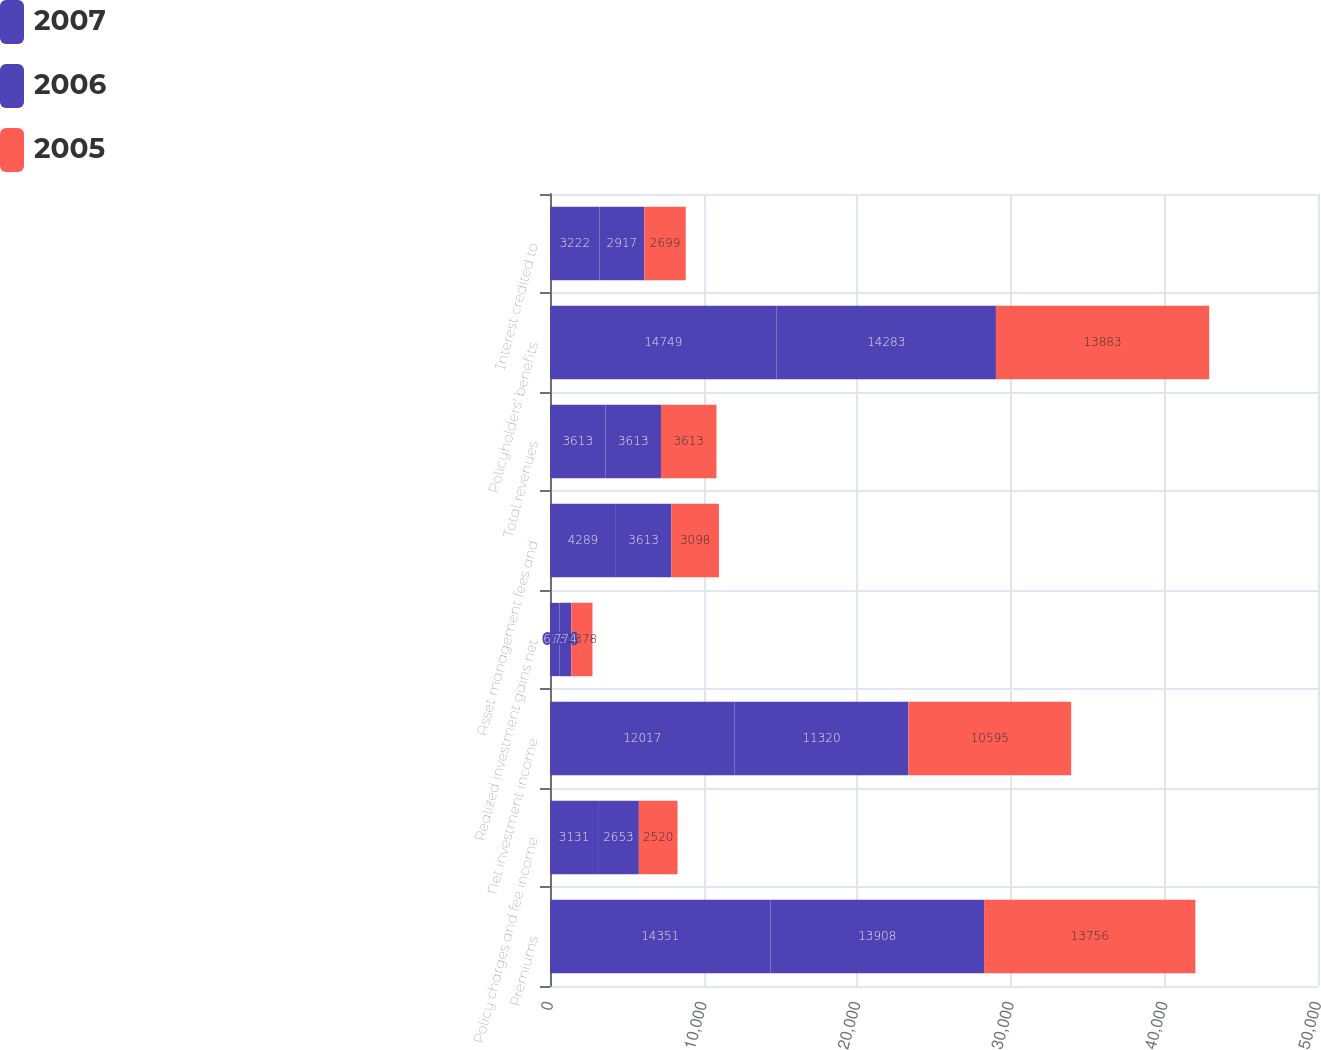Convert chart to OTSL. <chart><loc_0><loc_0><loc_500><loc_500><stacked_bar_chart><ecel><fcel>Premiums<fcel>Policy charges and fee income<fcel>Net investment income<fcel>Realized investment gains net<fcel>Asset management fees and<fcel>Total revenues<fcel>Policyholders' benefits<fcel>Interest credited to<nl><fcel>2007<fcel>14351<fcel>3131<fcel>12017<fcel>613<fcel>4289<fcel>3613<fcel>14749<fcel>3222<nl><fcel>2006<fcel>13908<fcel>2653<fcel>11320<fcel>774<fcel>3613<fcel>3613<fcel>14283<fcel>2917<nl><fcel>2005<fcel>13756<fcel>2520<fcel>10595<fcel>1378<fcel>3098<fcel>3613<fcel>13883<fcel>2699<nl></chart> 